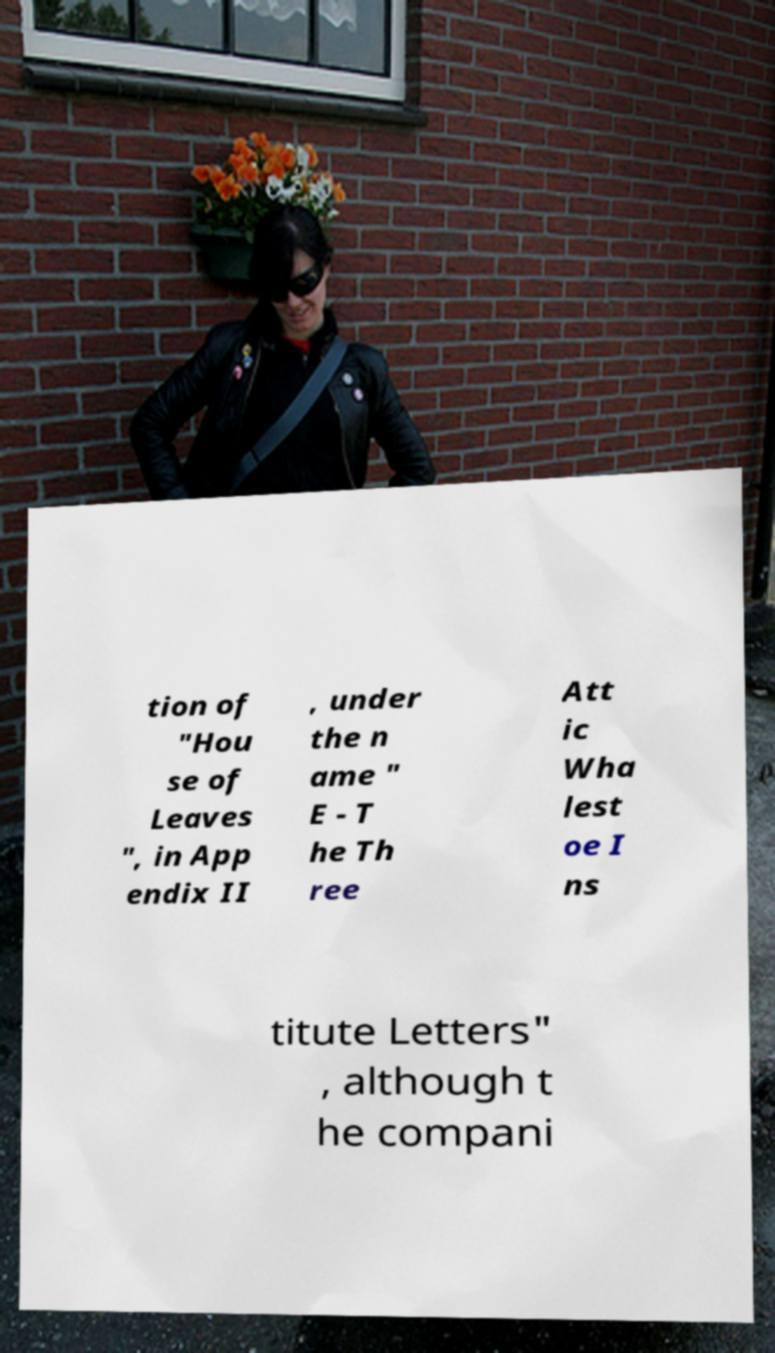I need the written content from this picture converted into text. Can you do that? tion of "Hou se of Leaves ", in App endix II , under the n ame " E - T he Th ree Att ic Wha lest oe I ns titute Letters" , although t he compani 